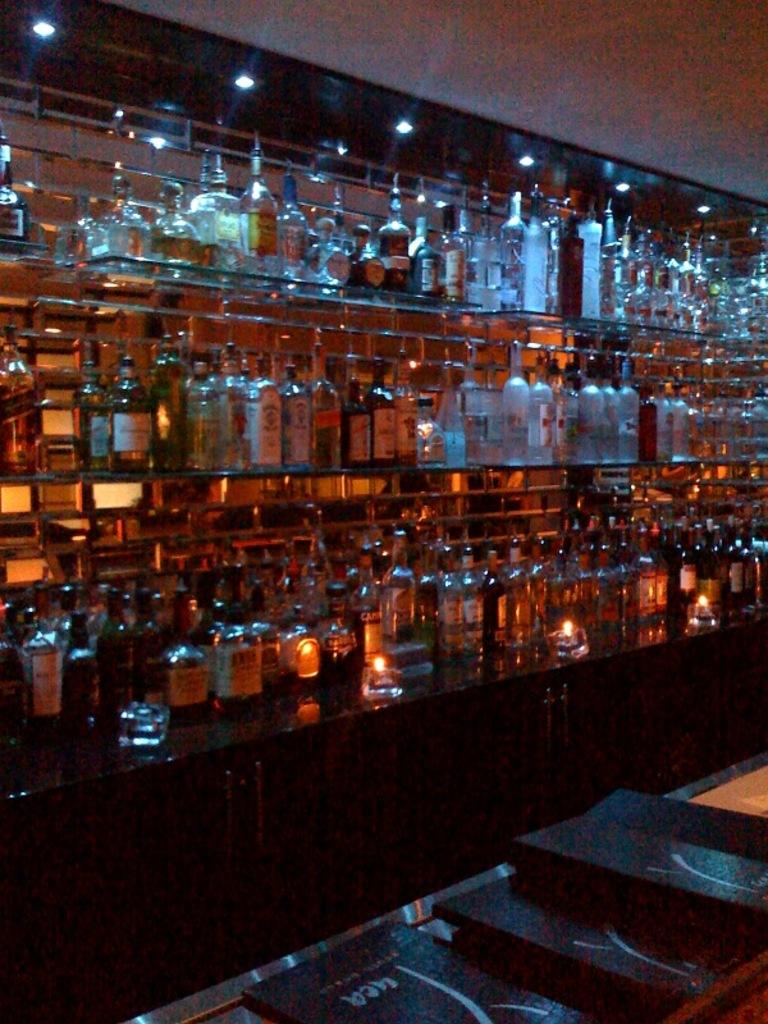What objects are located in the center of the image? There are glass bottles in the center of the image. What can be seen on the roof at the top side of the image? There are lamps on the roof at the top side. What type of items are present at the bottom side of the image? It appears that there are books at the bottom side of the image. How many friends can be seen interacting with the clam in the image? There is no clam or friends present in the image. 